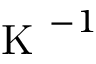Convert formula to latex. <formula><loc_0><loc_0><loc_500><loc_500>K ^ { - 1 }</formula> 